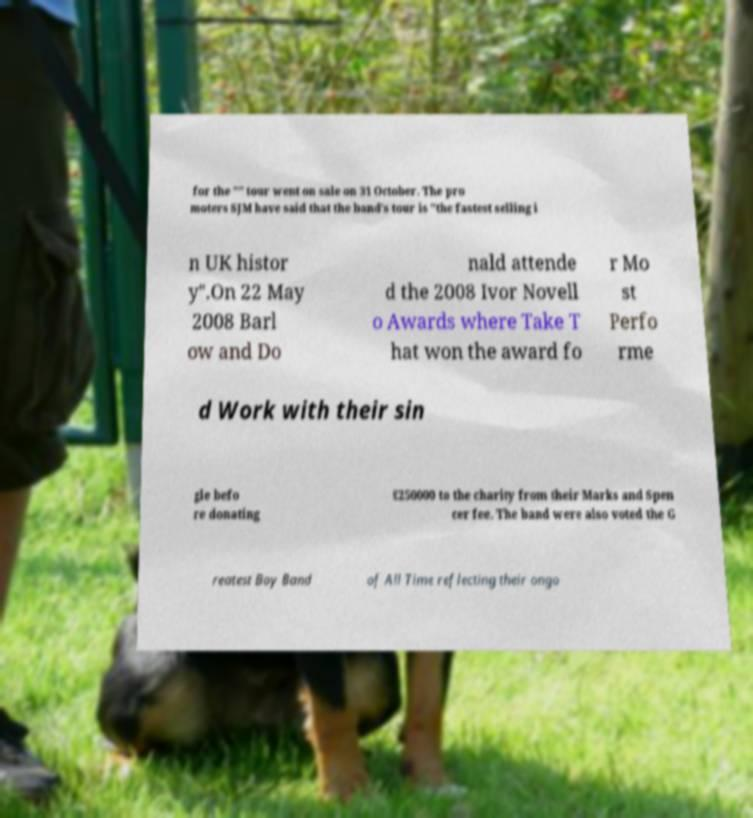Please read and relay the text visible in this image. What does it say? for the "" tour went on sale on 31 October. The pro moters SJM have said that the band's tour is "the fastest selling i n UK histor y".On 22 May 2008 Barl ow and Do nald attende d the 2008 Ivor Novell o Awards where Take T hat won the award fo r Mo st Perfo rme d Work with their sin gle befo re donating £250000 to the charity from their Marks and Spen cer fee. The band were also voted the G reatest Boy Band of All Time reflecting their ongo 